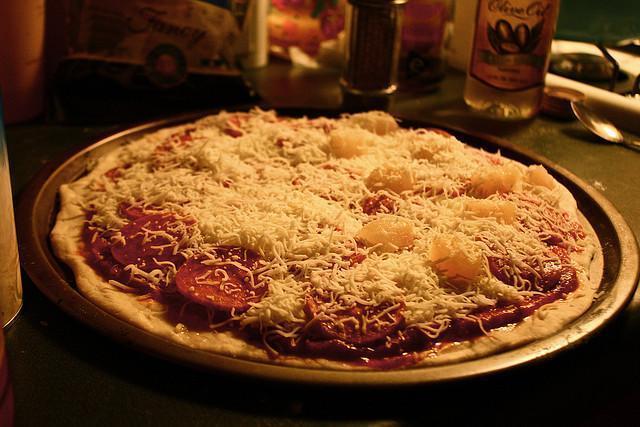How many bottles are there?
Give a very brief answer. 3. 